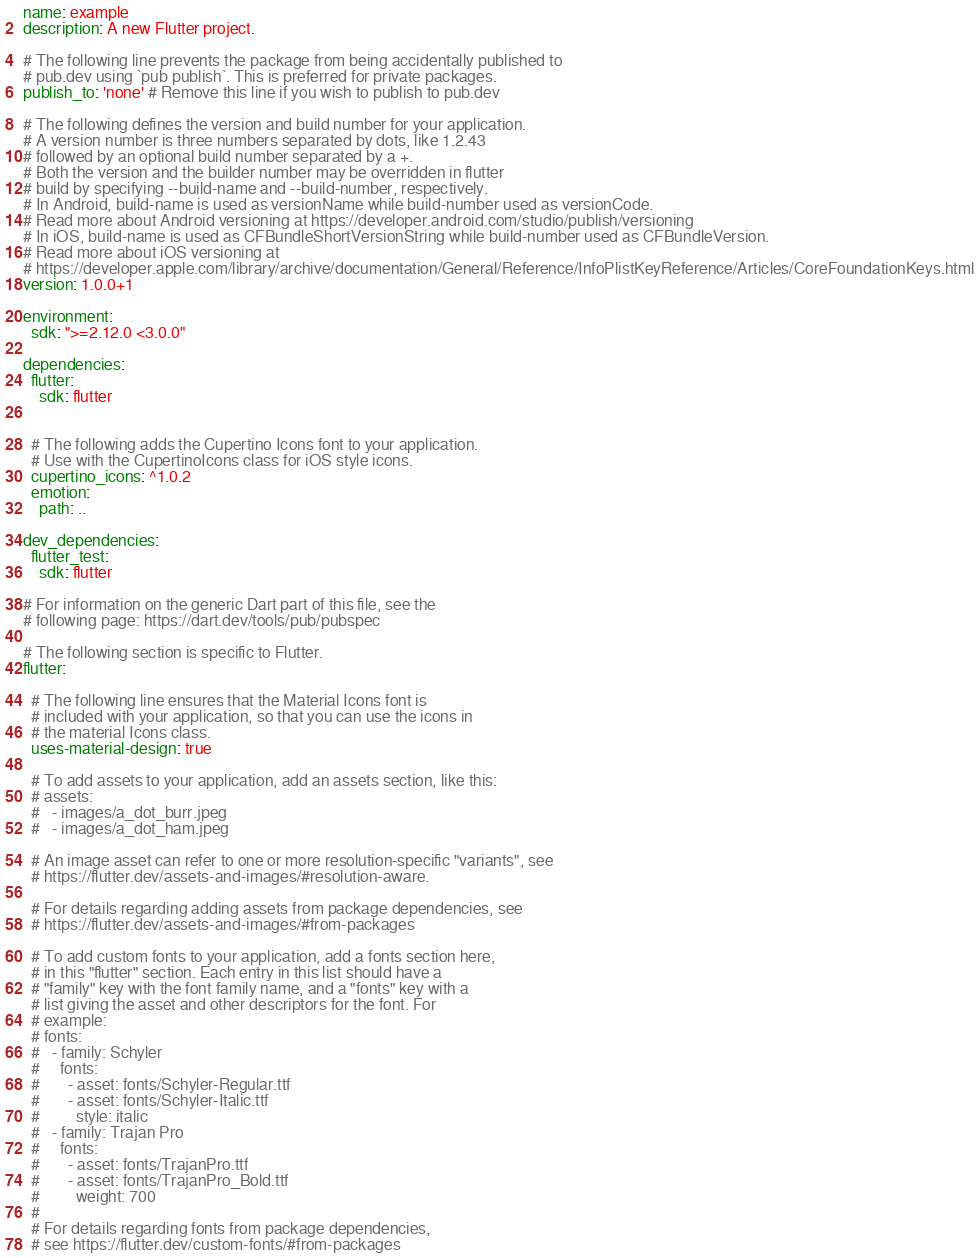<code> <loc_0><loc_0><loc_500><loc_500><_YAML_>name: example
description: A new Flutter project.

# The following line prevents the package from being accidentally published to
# pub.dev using `pub publish`. This is preferred for private packages.
publish_to: 'none' # Remove this line if you wish to publish to pub.dev

# The following defines the version and build number for your application.
# A version number is three numbers separated by dots, like 1.2.43
# followed by an optional build number separated by a +.
# Both the version and the builder number may be overridden in flutter
# build by specifying --build-name and --build-number, respectively.
# In Android, build-name is used as versionName while build-number used as versionCode.
# Read more about Android versioning at https://developer.android.com/studio/publish/versioning
# In iOS, build-name is used as CFBundleShortVersionString while build-number used as CFBundleVersion.
# Read more about iOS versioning at
# https://developer.apple.com/library/archive/documentation/General/Reference/InfoPlistKeyReference/Articles/CoreFoundationKeys.html
version: 1.0.0+1

environment:
  sdk: ">=2.12.0 <3.0.0"

dependencies:
  flutter:
    sdk: flutter


  # The following adds the Cupertino Icons font to your application.
  # Use with the CupertinoIcons class for iOS style icons.
  cupertino_icons: ^1.0.2
  emotion:
    path: ..

dev_dependencies:
  flutter_test:
    sdk: flutter

# For information on the generic Dart part of this file, see the
# following page: https://dart.dev/tools/pub/pubspec

# The following section is specific to Flutter.
flutter:

  # The following line ensures that the Material Icons font is
  # included with your application, so that you can use the icons in
  # the material Icons class.
  uses-material-design: true

  # To add assets to your application, add an assets section, like this:
  # assets:
  #   - images/a_dot_burr.jpeg
  #   - images/a_dot_ham.jpeg

  # An image asset can refer to one or more resolution-specific "variants", see
  # https://flutter.dev/assets-and-images/#resolution-aware.

  # For details regarding adding assets from package dependencies, see
  # https://flutter.dev/assets-and-images/#from-packages

  # To add custom fonts to your application, add a fonts section here,
  # in this "flutter" section. Each entry in this list should have a
  # "family" key with the font family name, and a "fonts" key with a
  # list giving the asset and other descriptors for the font. For
  # example:
  # fonts:
  #   - family: Schyler
  #     fonts:
  #       - asset: fonts/Schyler-Regular.ttf
  #       - asset: fonts/Schyler-Italic.ttf
  #         style: italic
  #   - family: Trajan Pro
  #     fonts:
  #       - asset: fonts/TrajanPro.ttf
  #       - asset: fonts/TrajanPro_Bold.ttf
  #         weight: 700
  #
  # For details regarding fonts from package dependencies,
  # see https://flutter.dev/custom-fonts/#from-packages
</code> 